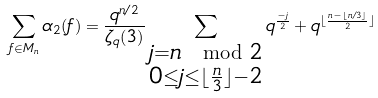<formula> <loc_0><loc_0><loc_500><loc_500>\sum _ { f \in M _ { n } } \alpha _ { 2 } ( f ) = \frac { q ^ { n / 2 } } { \zeta _ { q } ( 3 ) } \sum _ { \substack { j = n \mod 2 \\ 0 \leq j \leq \lfloor \frac { n } { 3 } \rfloor - 2 } } q ^ { \frac { - j } { 2 } } + q ^ { \lfloor { \frac { n - \lfloor n / 3 \rfloor } { 2 } \rfloor } }</formula> 